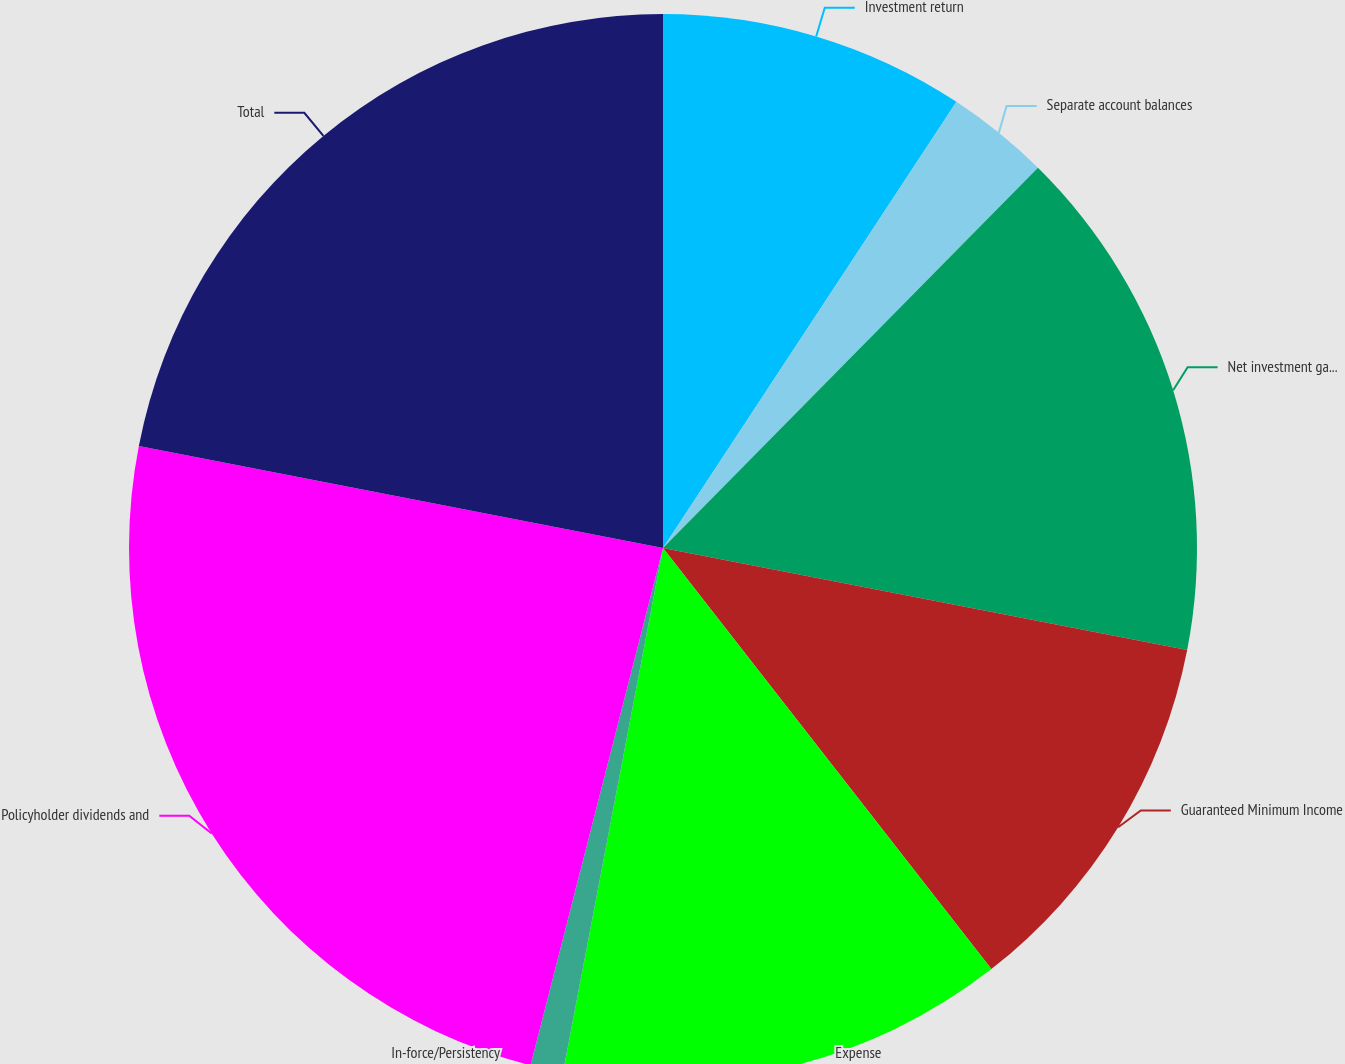Convert chart to OTSL. <chart><loc_0><loc_0><loc_500><loc_500><pie_chart><fcel>Investment return<fcel>Separate account balances<fcel>Net investment gain (loss)<fcel>Guaranteed Minimum Income<fcel>Expense<fcel>In-force/Persistency<fcel>Policyholder dividends and<fcel>Total<nl><fcel>9.26%<fcel>3.13%<fcel>15.67%<fcel>11.4%<fcel>13.54%<fcel>0.99%<fcel>24.07%<fcel>21.94%<nl></chart> 